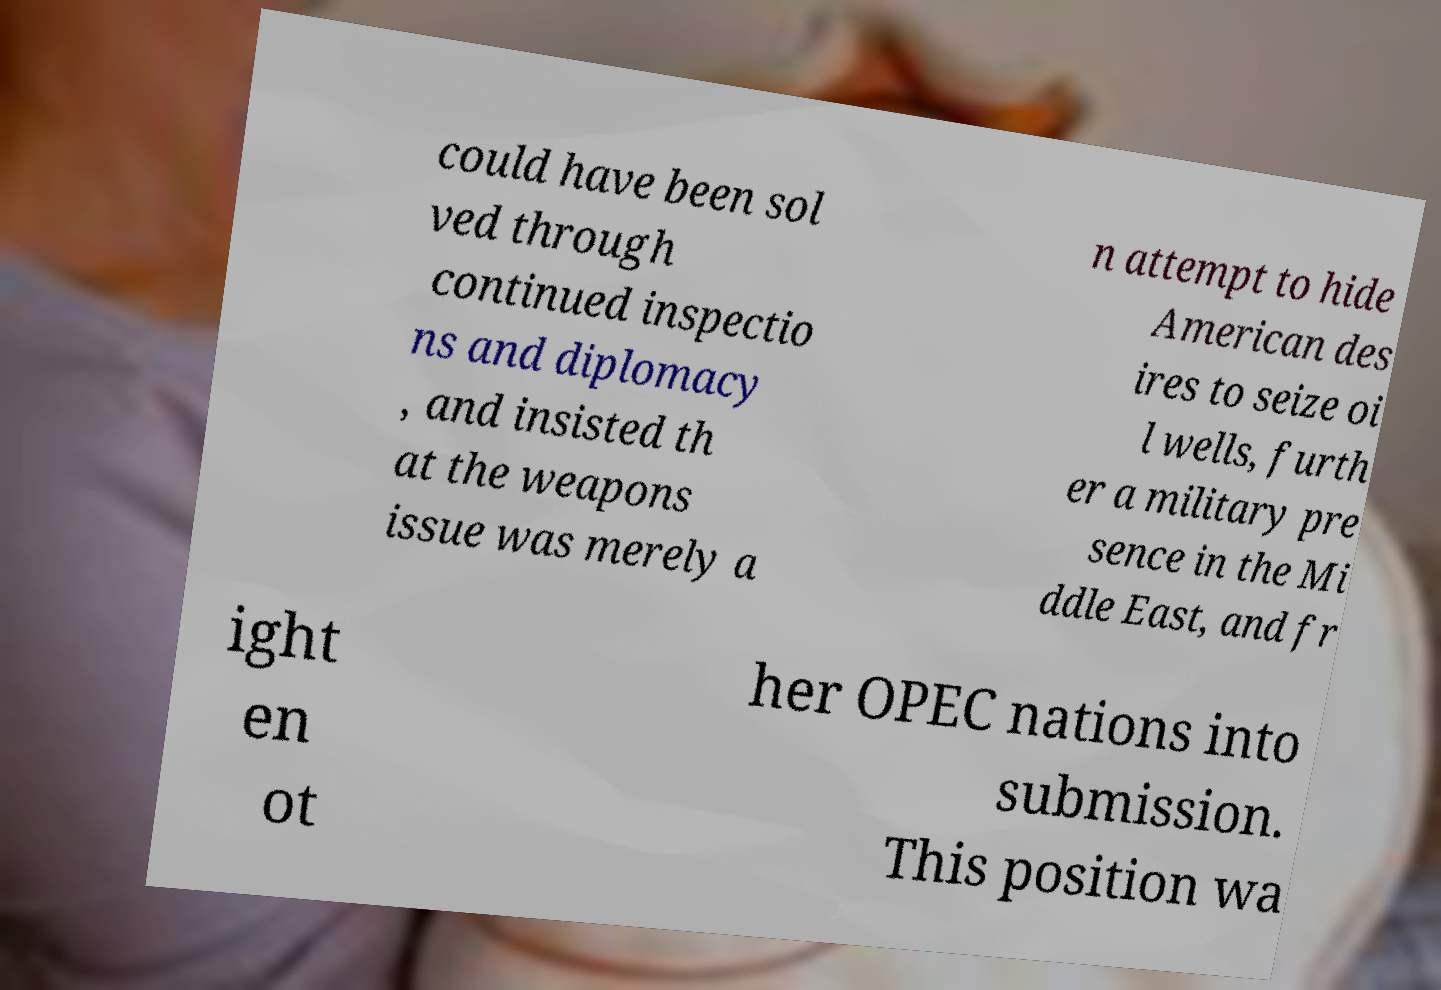What messages or text are displayed in this image? I need them in a readable, typed format. could have been sol ved through continued inspectio ns and diplomacy , and insisted th at the weapons issue was merely a n attempt to hide American des ires to seize oi l wells, furth er a military pre sence in the Mi ddle East, and fr ight en ot her OPEC nations into submission. This position wa 